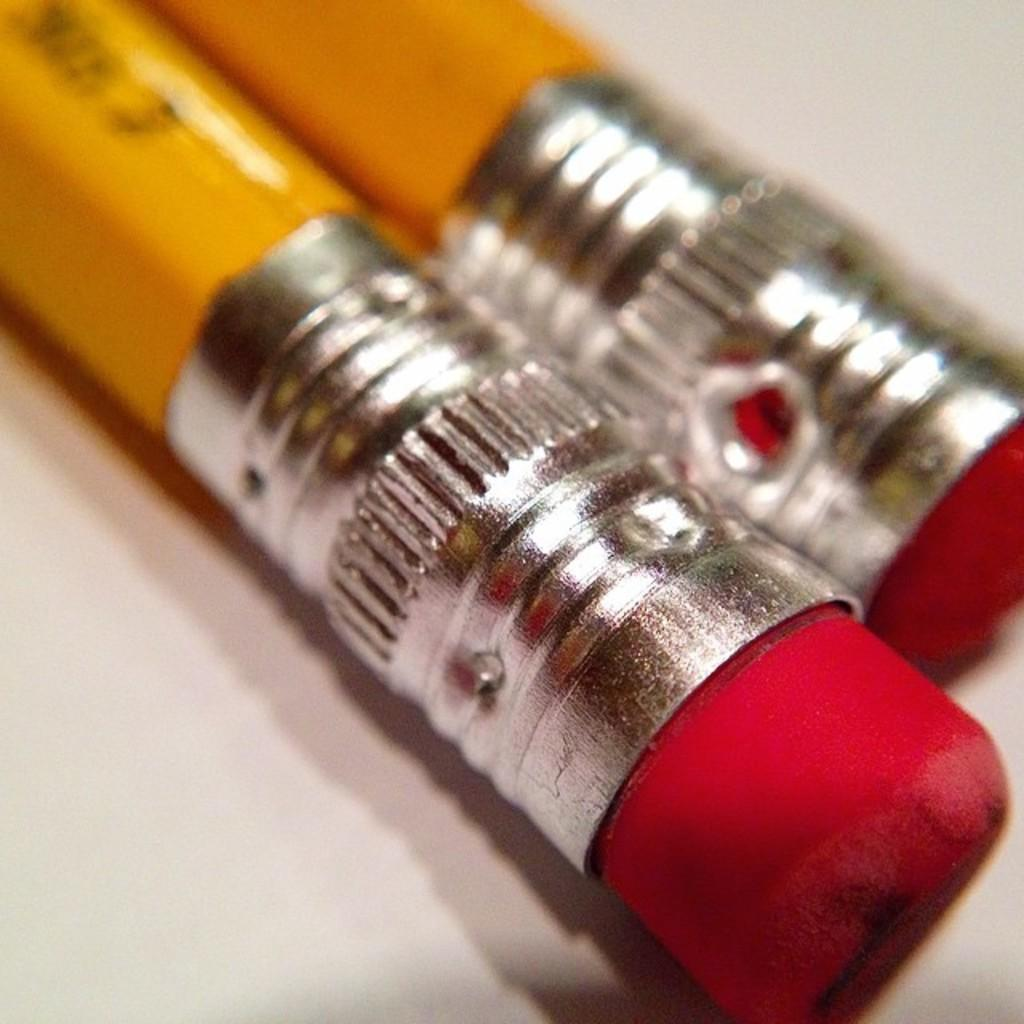How many pencils are visible in the image? There are two pencils in the image. What is attached to the pencils? There are objects attached to the pencils. What is the color of the surface on which the pencils are placed? The pencils are on a white color surface. What type of ornament is hanging from the pencils in the image? There is no ornament hanging from the pencils in the image. 